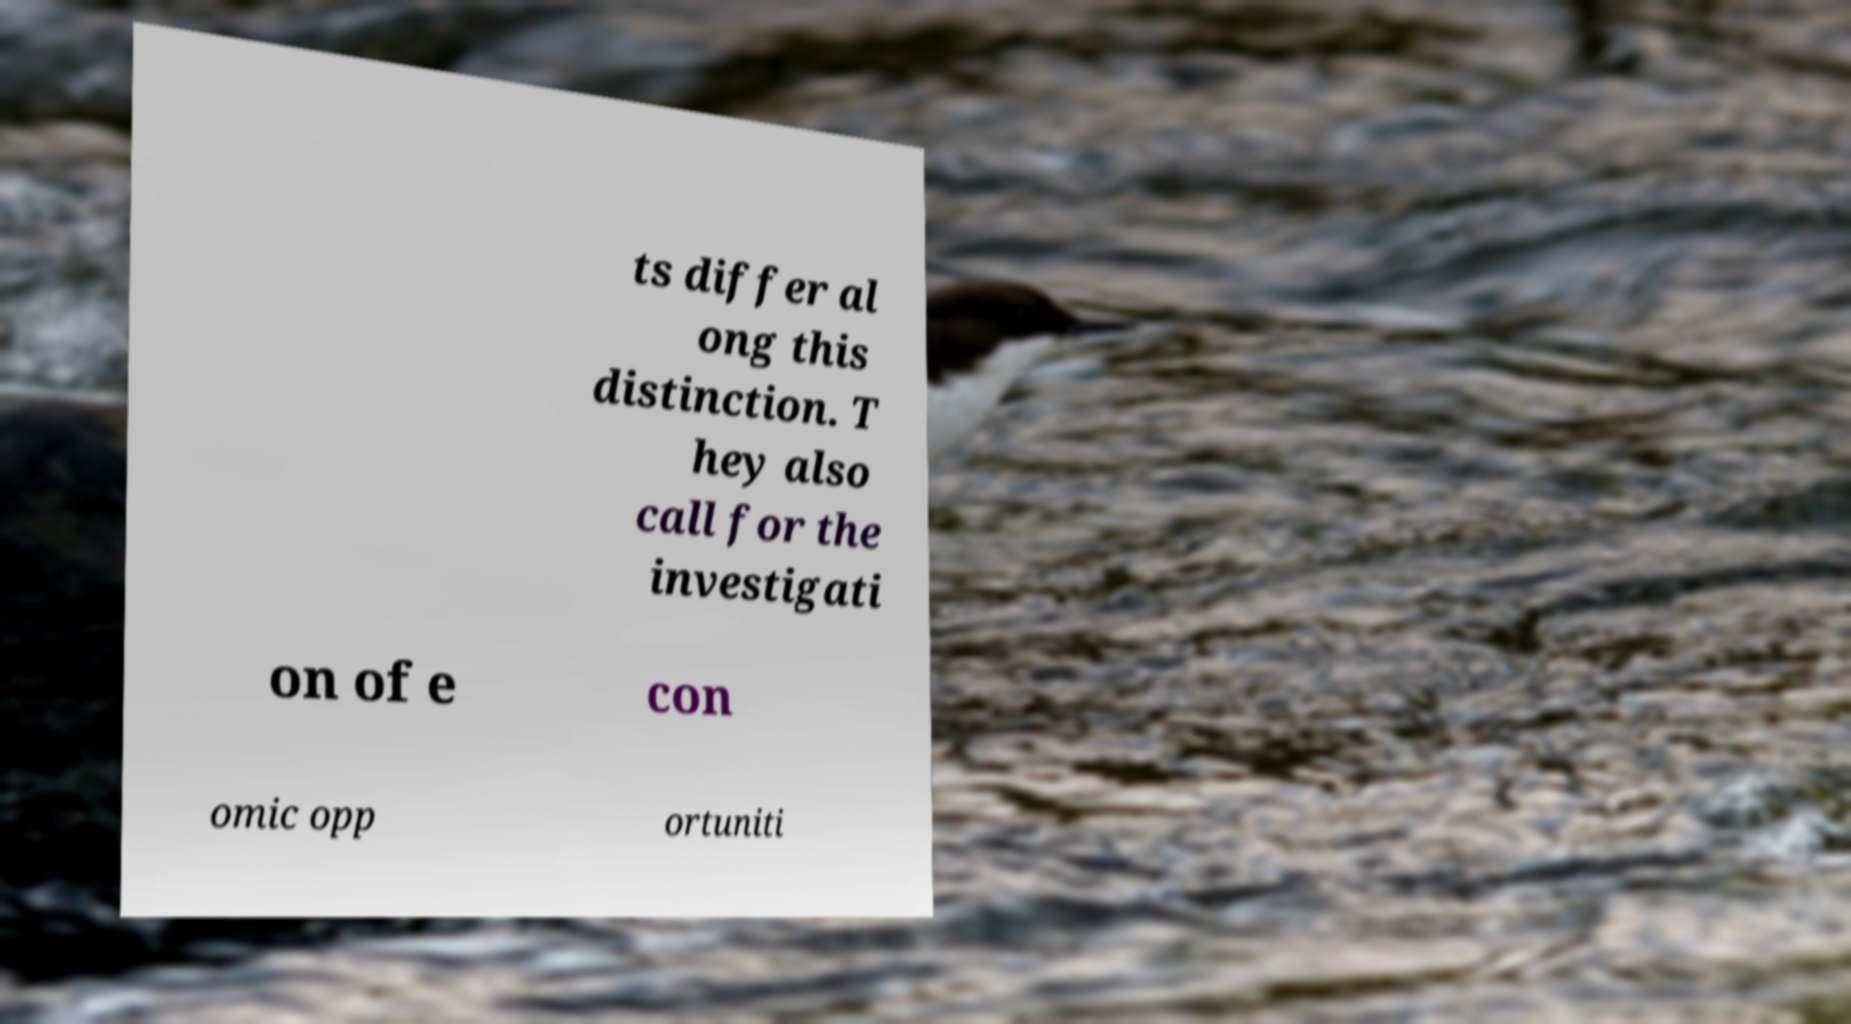There's text embedded in this image that I need extracted. Can you transcribe it verbatim? ts differ al ong this distinction. T hey also call for the investigati on of e con omic opp ortuniti 